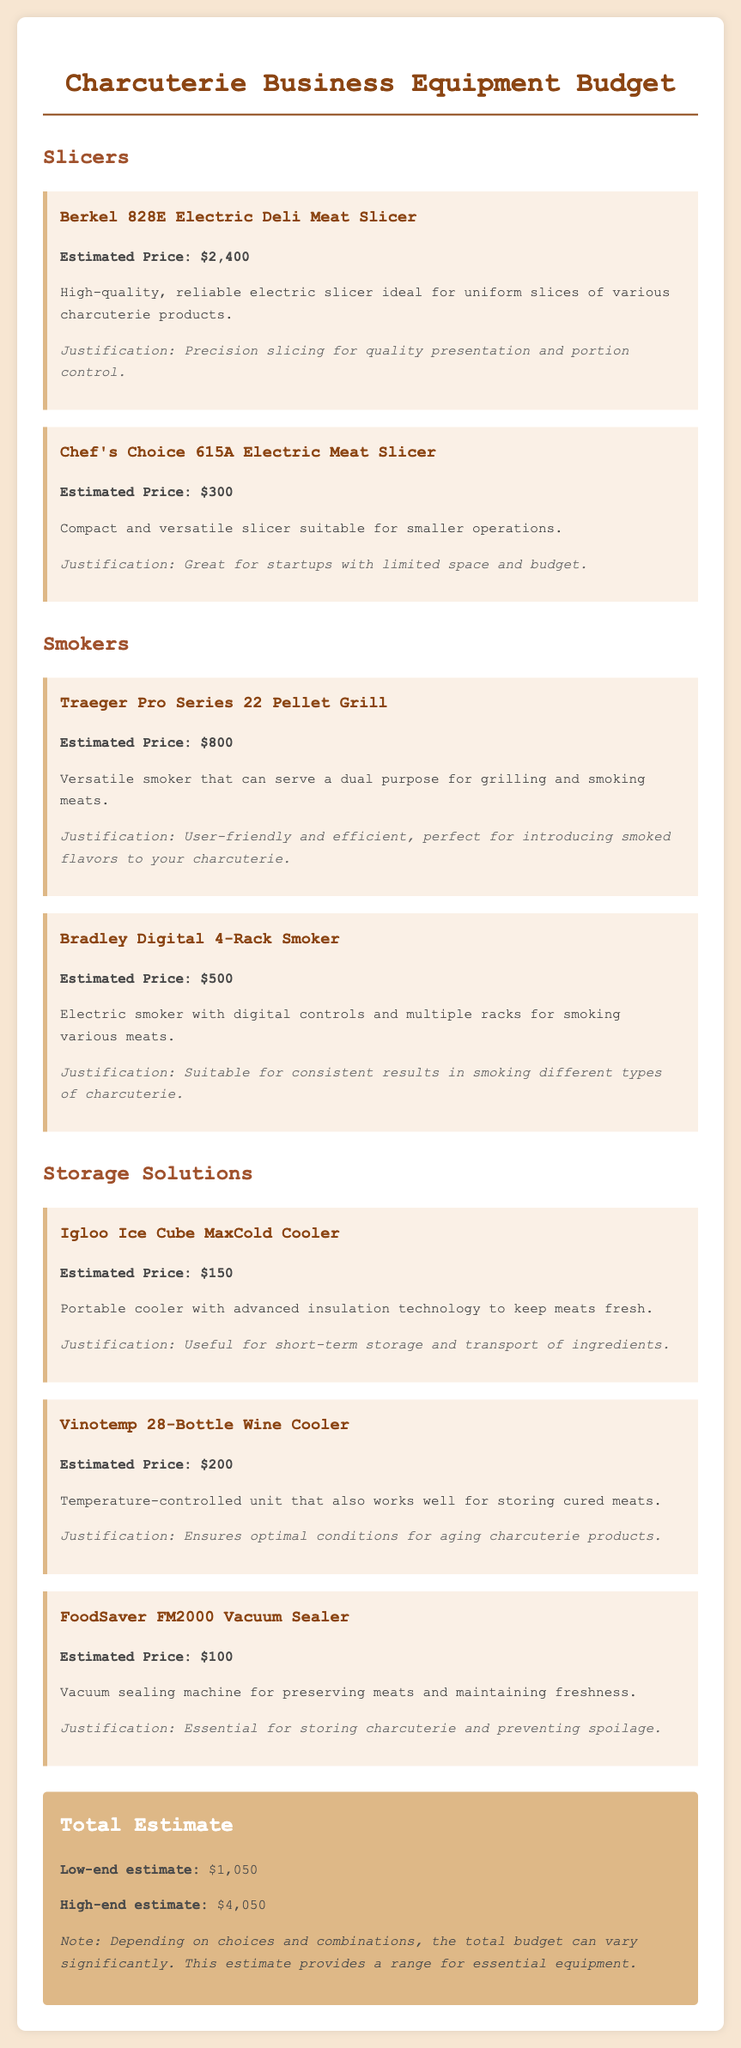What is the estimated price of the Berkel 828E Electric Deli Meat Slicer? The estimated price is listed in the document.
Answer: $2,400 How many storage solutions are listed in the document? The document states the number of distinct storage solutions available.
Answer: 3 What is the total low-end estimate of the equipment budget? The total low-end estimate is explicitly mentioned in the document.
Answer: $1,050 What is the purpose of the FoodSaver FM2000 Vacuum Sealer? The purpose is described in the equipment item section related to storage.
Answer: Preserving meats Which smoker is listed as electric with digital controls? The detailed features of the smokers show which one has digital controls.
Answer: Bradley Digital 4-Rack Smoker What is the estimated price range between low-end and high-end estimates? The document provides the range of estimates for the budget.
Answer: $3,000 What equipment is described for its versatility in grilling and smoking? The description of the smoker equipment highlights its dual purpose.
Answer: Traeger Pro Series 22 Pellet Grill What is the estimated price of the Chef's Choice 615A Electric Meat Slicer? The estimated price is provided in the respective equipment item.
Answer: $300 